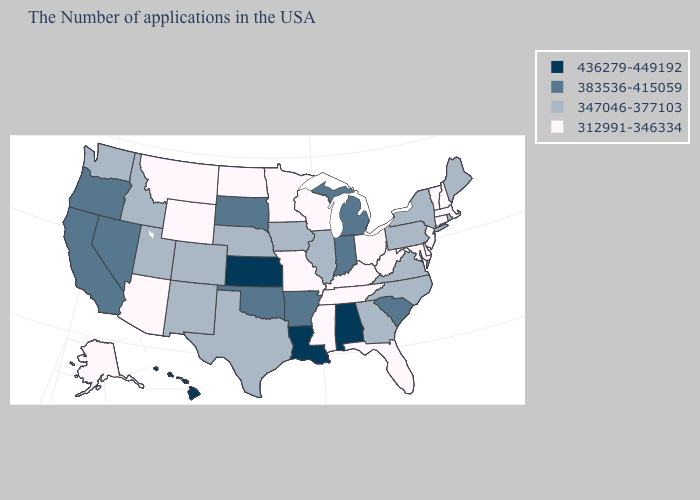What is the lowest value in the South?
Concise answer only. 312991-346334. Name the states that have a value in the range 312991-346334?
Short answer required. Massachusetts, New Hampshire, Vermont, Connecticut, New Jersey, Delaware, Maryland, West Virginia, Ohio, Florida, Kentucky, Tennessee, Wisconsin, Mississippi, Missouri, Minnesota, North Dakota, Wyoming, Montana, Arizona, Alaska. What is the value of New York?
Quick response, please. 347046-377103. Does Virginia have a lower value than Hawaii?
Keep it brief. Yes. Does Missouri have the lowest value in the MidWest?
Quick response, please. Yes. Name the states that have a value in the range 347046-377103?
Quick response, please. Maine, Rhode Island, New York, Pennsylvania, Virginia, North Carolina, Georgia, Illinois, Iowa, Nebraska, Texas, Colorado, New Mexico, Utah, Idaho, Washington. Name the states that have a value in the range 383536-415059?
Give a very brief answer. South Carolina, Michigan, Indiana, Arkansas, Oklahoma, South Dakota, Nevada, California, Oregon. What is the highest value in the USA?
Write a very short answer. 436279-449192. Does Mississippi have a higher value than Illinois?
Quick response, please. No. What is the value of Mississippi?
Quick response, please. 312991-346334. Does Utah have a higher value than North Dakota?
Concise answer only. Yes. What is the value of Illinois?
Concise answer only. 347046-377103. Does Colorado have a lower value than Massachusetts?
Be succinct. No. Name the states that have a value in the range 312991-346334?
Give a very brief answer. Massachusetts, New Hampshire, Vermont, Connecticut, New Jersey, Delaware, Maryland, West Virginia, Ohio, Florida, Kentucky, Tennessee, Wisconsin, Mississippi, Missouri, Minnesota, North Dakota, Wyoming, Montana, Arizona, Alaska. 